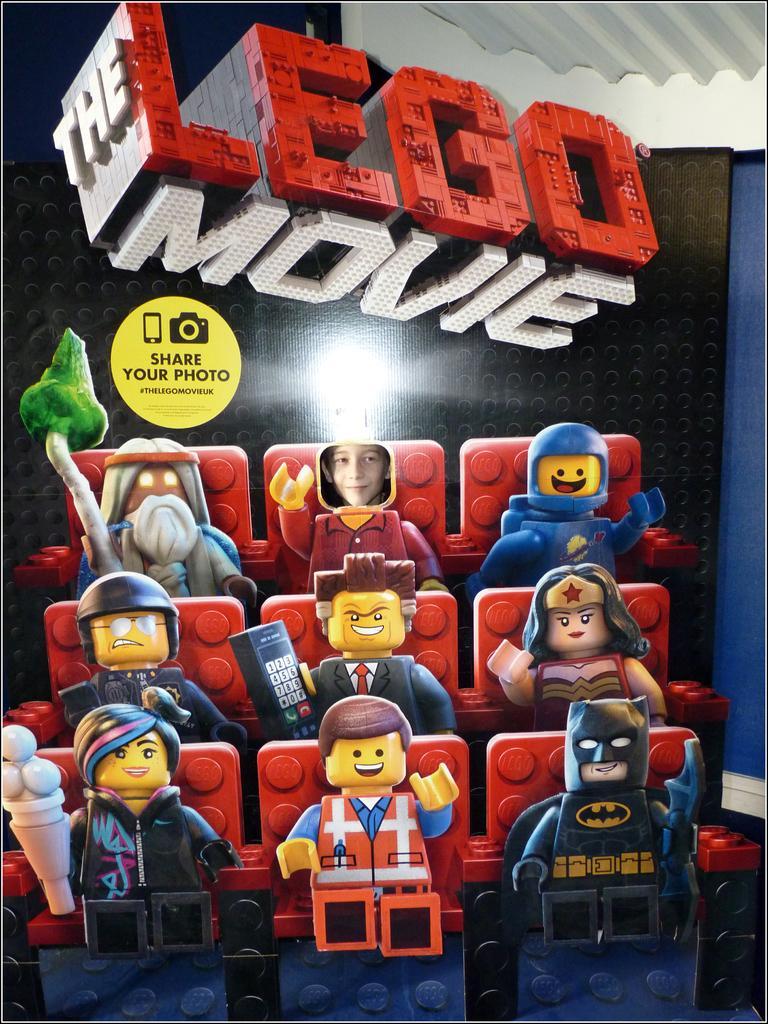Describe this image in one or two sentences. In this picture I can see the toys which are placed near to the wall. In the top right I can see the roof. 